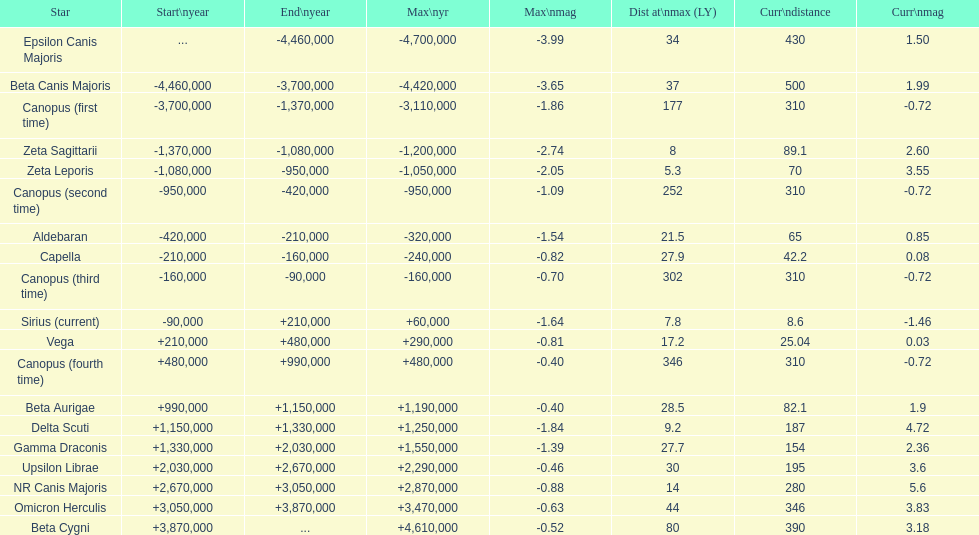How much farther (in ly) is epsilon canis majoris than zeta sagittarii? 26. Would you be able to parse every entry in this table? {'header': ['Star', 'Start\\nyear', 'End\\nyear', 'Max\\nyr', 'Max\\nmag', 'Dist at\\nmax (LY)', 'Curr\\ndistance', 'Curr\\nmag'], 'rows': [['Epsilon Canis Majoris', '...', '-4,460,000', '-4,700,000', '-3.99', '34', '430', '1.50'], ['Beta Canis Majoris', '-4,460,000', '-3,700,000', '-4,420,000', '-3.65', '37', '500', '1.99'], ['Canopus (first time)', '-3,700,000', '-1,370,000', '-3,110,000', '-1.86', '177', '310', '-0.72'], ['Zeta Sagittarii', '-1,370,000', '-1,080,000', '-1,200,000', '-2.74', '8', '89.1', '2.60'], ['Zeta Leporis', '-1,080,000', '-950,000', '-1,050,000', '-2.05', '5.3', '70', '3.55'], ['Canopus (second time)', '-950,000', '-420,000', '-950,000', '-1.09', '252', '310', '-0.72'], ['Aldebaran', '-420,000', '-210,000', '-320,000', '-1.54', '21.5', '65', '0.85'], ['Capella', '-210,000', '-160,000', '-240,000', '-0.82', '27.9', '42.2', '0.08'], ['Canopus (third time)', '-160,000', '-90,000', '-160,000', '-0.70', '302', '310', '-0.72'], ['Sirius (current)', '-90,000', '+210,000', '+60,000', '-1.64', '7.8', '8.6', '-1.46'], ['Vega', '+210,000', '+480,000', '+290,000', '-0.81', '17.2', '25.04', '0.03'], ['Canopus (fourth time)', '+480,000', '+990,000', '+480,000', '-0.40', '346', '310', '-0.72'], ['Beta Aurigae', '+990,000', '+1,150,000', '+1,190,000', '-0.40', '28.5', '82.1', '1.9'], ['Delta Scuti', '+1,150,000', '+1,330,000', '+1,250,000', '-1.84', '9.2', '187', '4.72'], ['Gamma Draconis', '+1,330,000', '+2,030,000', '+1,550,000', '-1.39', '27.7', '154', '2.36'], ['Upsilon Librae', '+2,030,000', '+2,670,000', '+2,290,000', '-0.46', '30', '195', '3.6'], ['NR Canis Majoris', '+2,670,000', '+3,050,000', '+2,870,000', '-0.88', '14', '280', '5.6'], ['Omicron Herculis', '+3,050,000', '+3,870,000', '+3,470,000', '-0.63', '44', '346', '3.83'], ['Beta Cygni', '+3,870,000', '...', '+4,610,000', '-0.52', '80', '390', '3.18']]} 